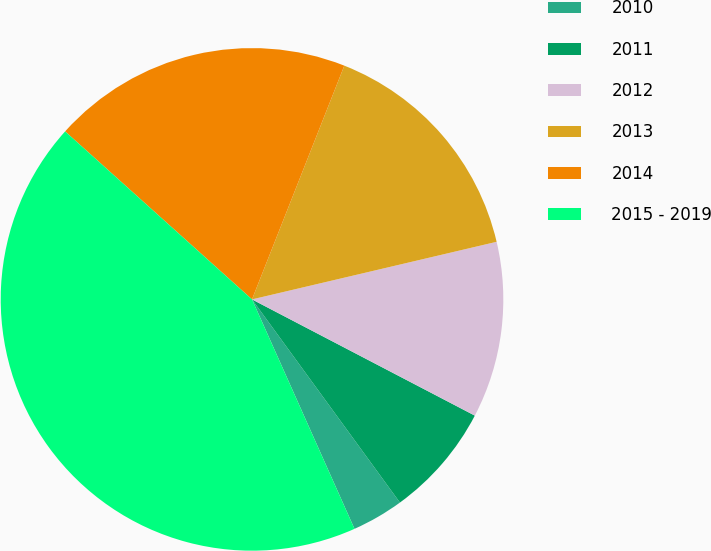Convert chart to OTSL. <chart><loc_0><loc_0><loc_500><loc_500><pie_chart><fcel>2010<fcel>2011<fcel>2012<fcel>2013<fcel>2014<fcel>2015 - 2019<nl><fcel>3.33%<fcel>7.33%<fcel>11.33%<fcel>15.33%<fcel>19.33%<fcel>43.33%<nl></chart> 